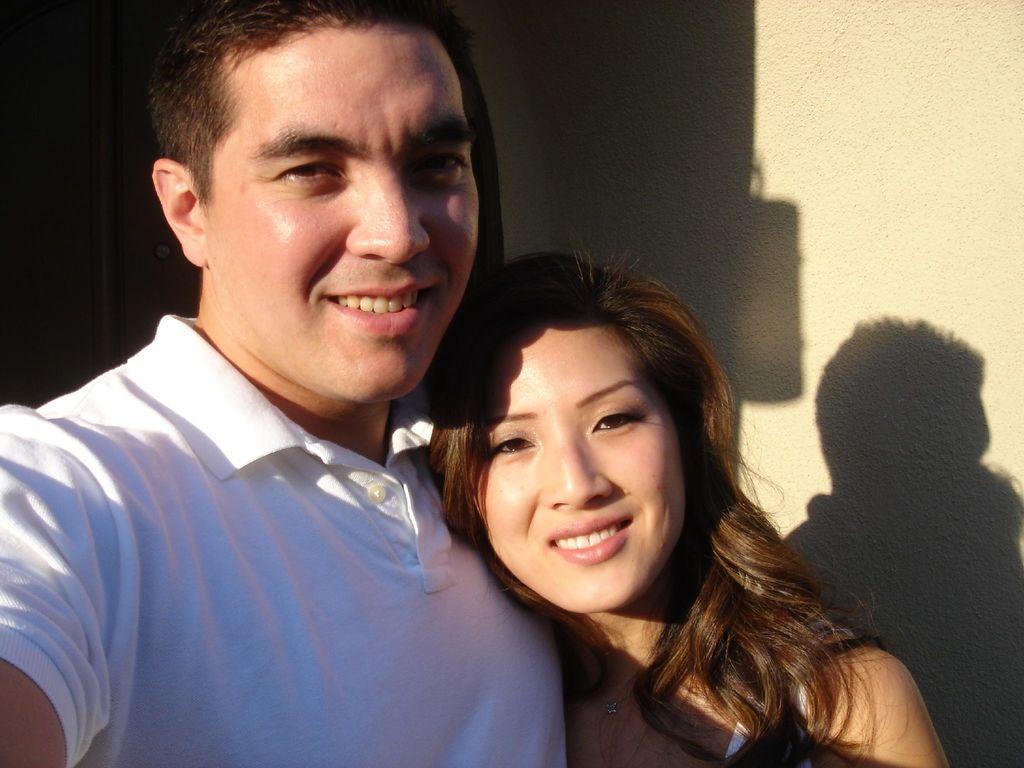Could you give a brief overview of what you see in this image? In this picture there is a man and a woman in the center of the image. 